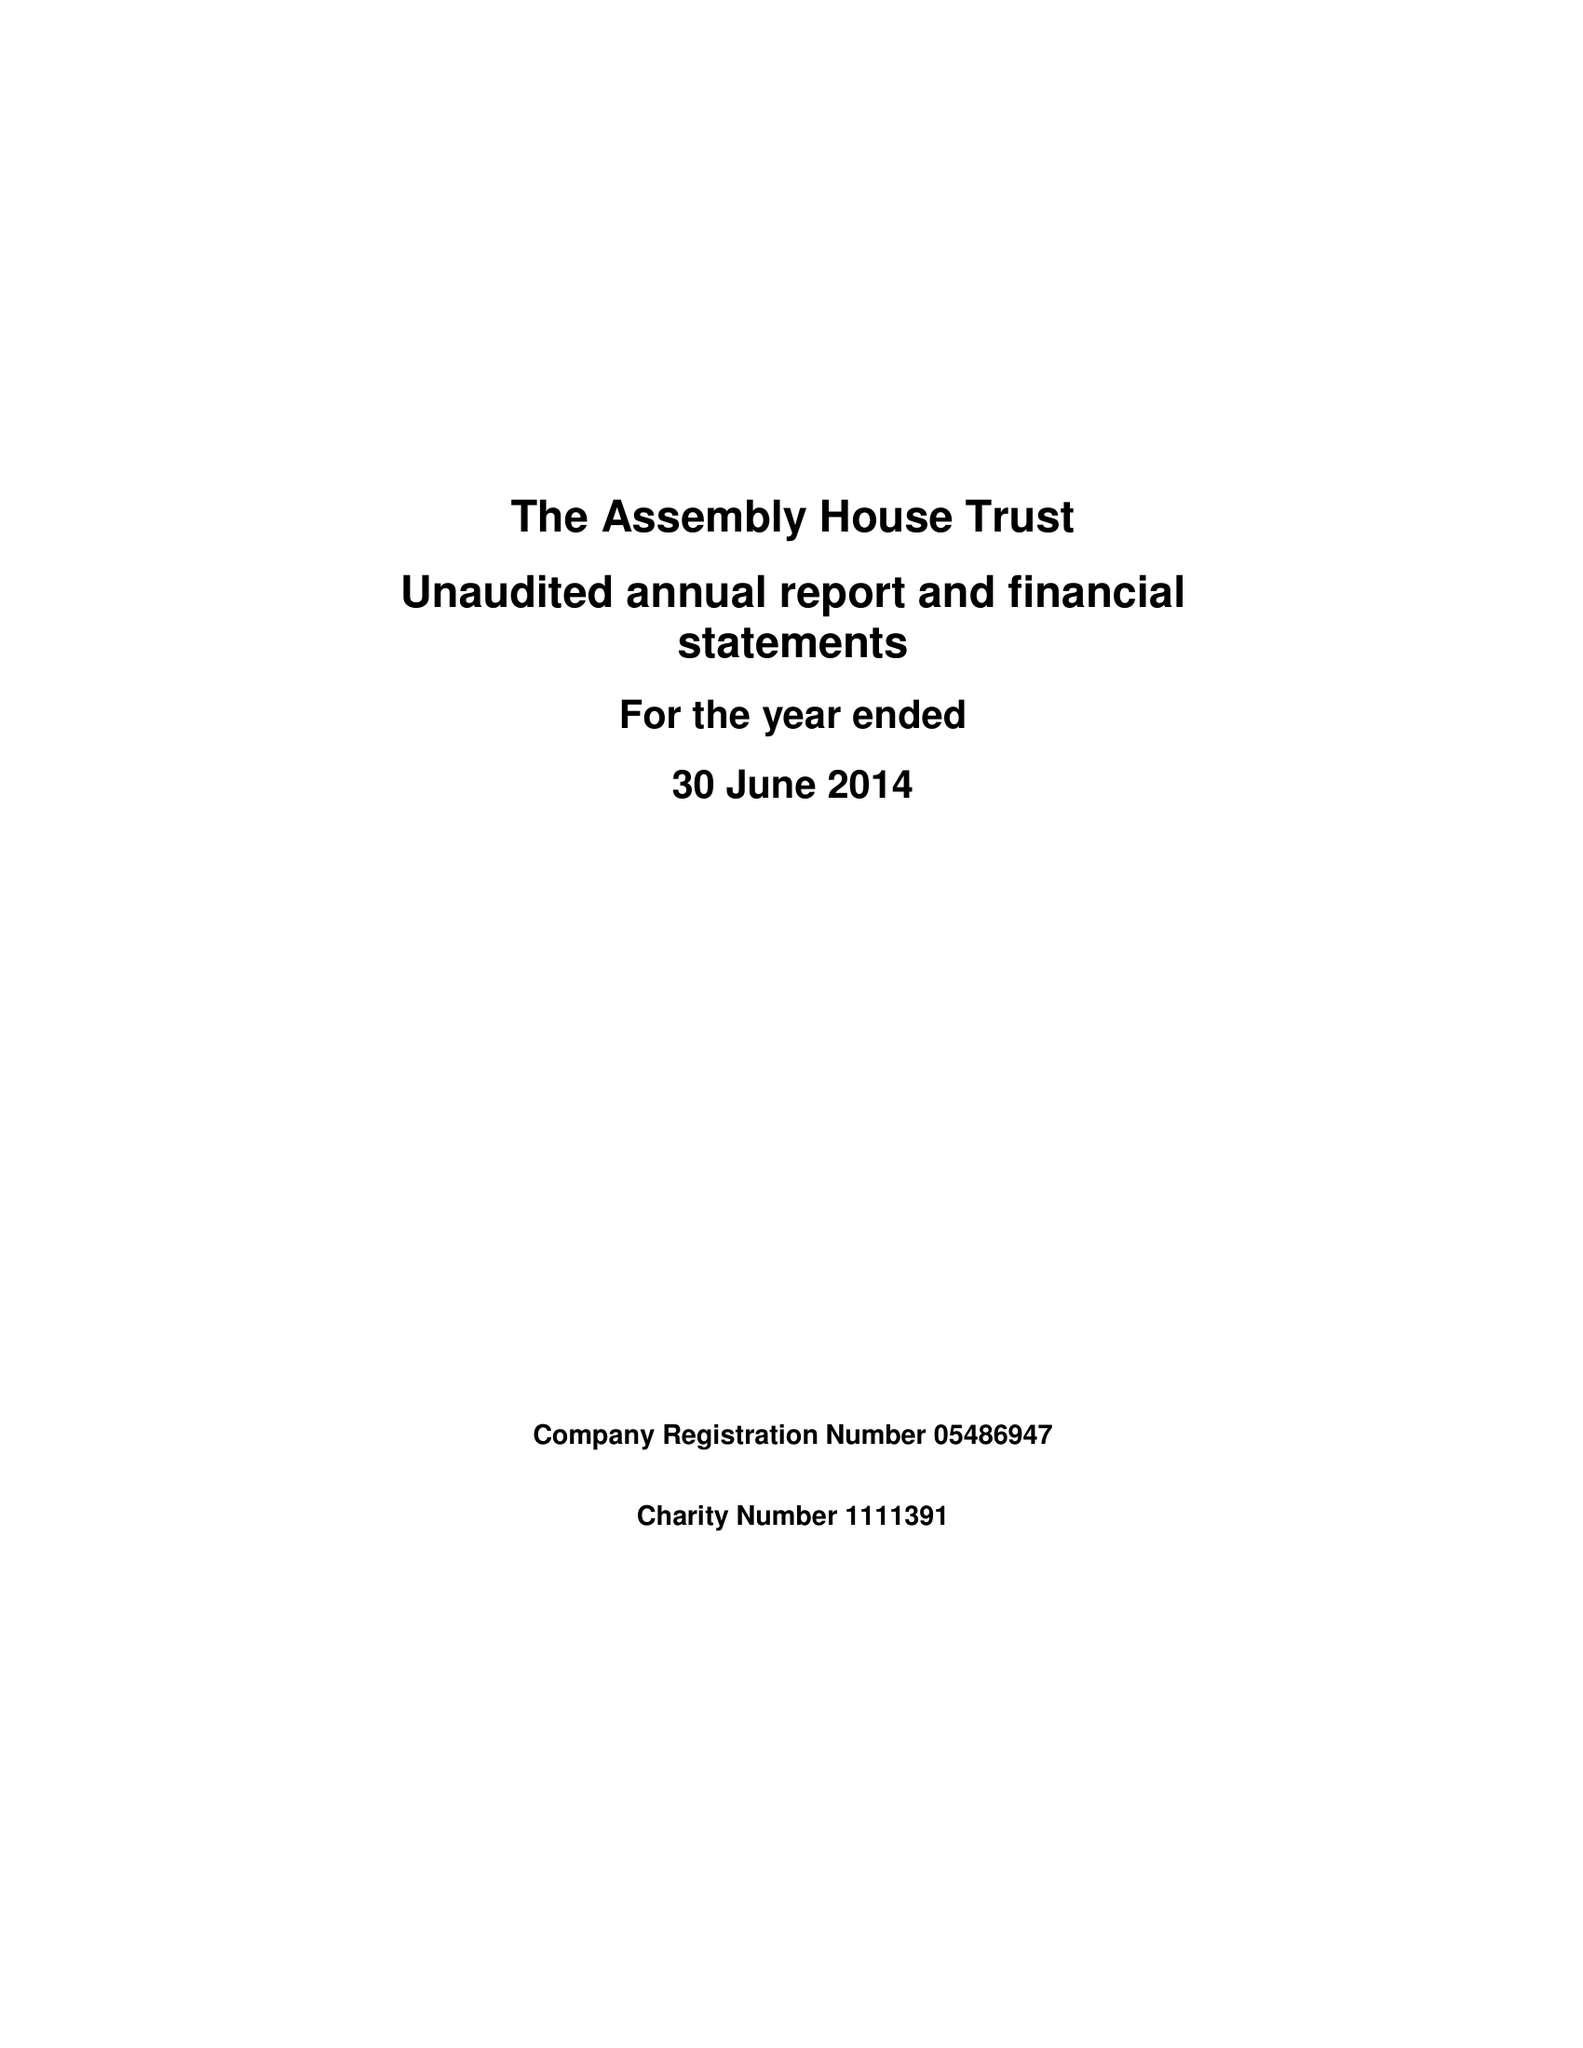What is the value for the address__street_line?
Answer the question using a single word or phrase. THEATRE STREET 